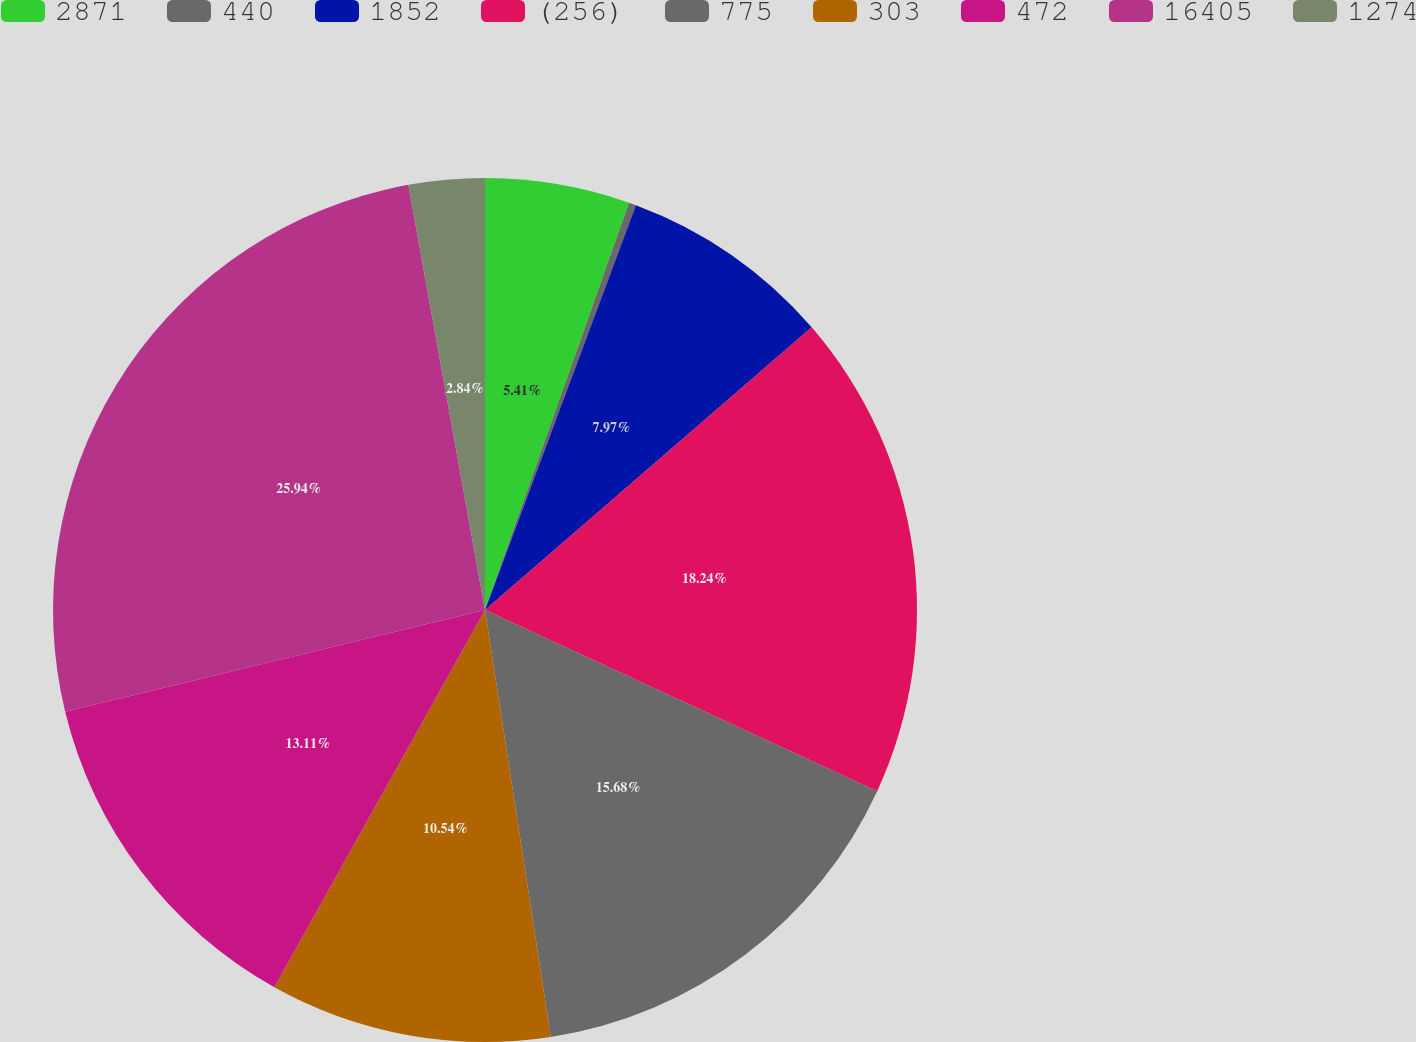Convert chart. <chart><loc_0><loc_0><loc_500><loc_500><pie_chart><fcel>2871<fcel>440<fcel>1852<fcel>(256)<fcel>775<fcel>303<fcel>472<fcel>16405<fcel>1274<nl><fcel>5.41%<fcel>0.27%<fcel>7.97%<fcel>18.24%<fcel>15.68%<fcel>10.54%<fcel>13.11%<fcel>25.95%<fcel>2.84%<nl></chart> 